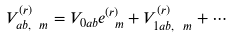<formula> <loc_0><loc_0><loc_500><loc_500>V _ { a b , \ m } ^ { ( r ) } = V _ { 0 a b } e ^ { ( r ) } _ { \ m } + V ^ { ( r ) } _ { 1 a b , \ m } + \cdots</formula> 